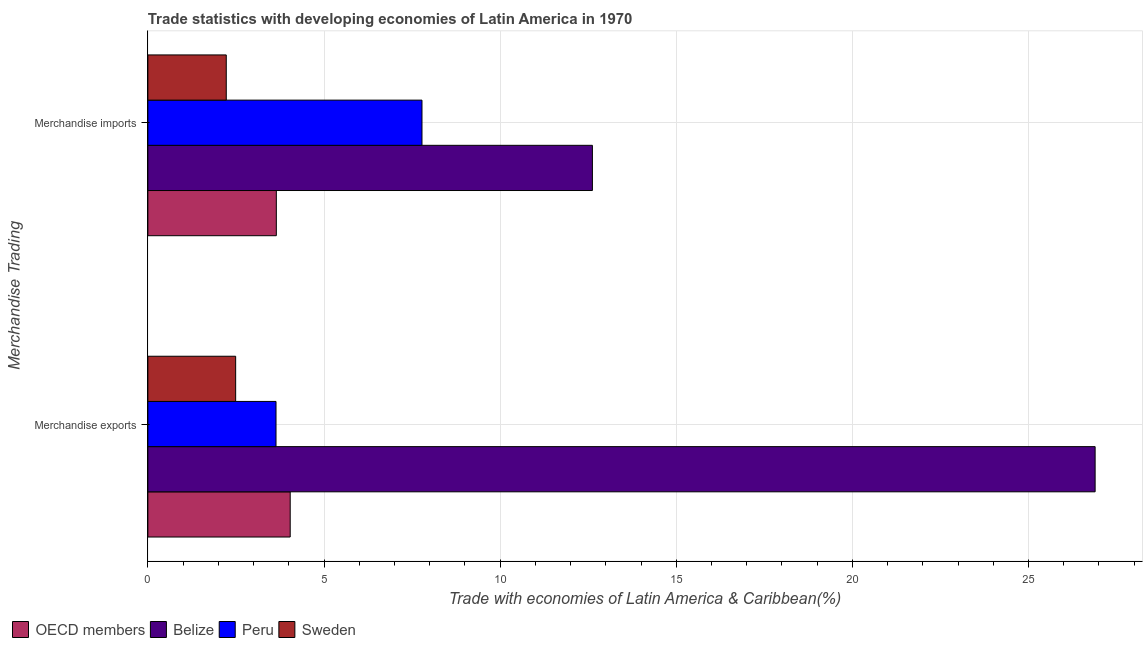Are the number of bars per tick equal to the number of legend labels?
Your response must be concise. Yes. Are the number of bars on each tick of the Y-axis equal?
Provide a succinct answer. Yes. How many bars are there on the 2nd tick from the bottom?
Make the answer very short. 4. What is the label of the 2nd group of bars from the top?
Make the answer very short. Merchandise exports. What is the merchandise exports in OECD members?
Offer a very short reply. 4.04. Across all countries, what is the maximum merchandise imports?
Your response must be concise. 12.62. Across all countries, what is the minimum merchandise imports?
Ensure brevity in your answer.  2.23. In which country was the merchandise imports maximum?
Offer a terse response. Belize. What is the total merchandise imports in the graph?
Ensure brevity in your answer.  26.27. What is the difference between the merchandise imports in Sweden and that in Peru?
Offer a terse response. -5.56. What is the difference between the merchandise imports in OECD members and the merchandise exports in Sweden?
Your answer should be compact. 1.15. What is the average merchandise exports per country?
Your answer should be very brief. 9.27. What is the difference between the merchandise imports and merchandise exports in Belize?
Offer a terse response. -14.27. What is the ratio of the merchandise imports in Peru to that in OECD members?
Provide a short and direct response. 2.13. Is the merchandise exports in Sweden less than that in Belize?
Give a very brief answer. Yes. In how many countries, is the merchandise exports greater than the average merchandise exports taken over all countries?
Make the answer very short. 1. What does the 2nd bar from the top in Merchandise imports represents?
Your response must be concise. Peru. How many bars are there?
Provide a short and direct response. 8. Are all the bars in the graph horizontal?
Ensure brevity in your answer.  Yes. How many countries are there in the graph?
Provide a succinct answer. 4. Does the graph contain any zero values?
Ensure brevity in your answer.  No. Does the graph contain grids?
Offer a terse response. Yes. Where does the legend appear in the graph?
Your answer should be compact. Bottom left. How many legend labels are there?
Your response must be concise. 4. How are the legend labels stacked?
Provide a short and direct response. Horizontal. What is the title of the graph?
Your response must be concise. Trade statistics with developing economies of Latin America in 1970. Does "Heavily indebted poor countries" appear as one of the legend labels in the graph?
Give a very brief answer. No. What is the label or title of the X-axis?
Ensure brevity in your answer.  Trade with economies of Latin America & Caribbean(%). What is the label or title of the Y-axis?
Your answer should be compact. Merchandise Trading. What is the Trade with economies of Latin America & Caribbean(%) in OECD members in Merchandise exports?
Your answer should be very brief. 4.04. What is the Trade with economies of Latin America & Caribbean(%) of Belize in Merchandise exports?
Provide a succinct answer. 26.89. What is the Trade with economies of Latin America & Caribbean(%) in Peru in Merchandise exports?
Offer a terse response. 3.64. What is the Trade with economies of Latin America & Caribbean(%) of Sweden in Merchandise exports?
Provide a succinct answer. 2.49. What is the Trade with economies of Latin America & Caribbean(%) in OECD members in Merchandise imports?
Your response must be concise. 3.65. What is the Trade with economies of Latin America & Caribbean(%) in Belize in Merchandise imports?
Give a very brief answer. 12.62. What is the Trade with economies of Latin America & Caribbean(%) of Peru in Merchandise imports?
Your response must be concise. 7.78. What is the Trade with economies of Latin America & Caribbean(%) in Sweden in Merchandise imports?
Make the answer very short. 2.23. Across all Merchandise Trading, what is the maximum Trade with economies of Latin America & Caribbean(%) of OECD members?
Give a very brief answer. 4.04. Across all Merchandise Trading, what is the maximum Trade with economies of Latin America & Caribbean(%) of Belize?
Ensure brevity in your answer.  26.89. Across all Merchandise Trading, what is the maximum Trade with economies of Latin America & Caribbean(%) of Peru?
Provide a short and direct response. 7.78. Across all Merchandise Trading, what is the maximum Trade with economies of Latin America & Caribbean(%) in Sweden?
Ensure brevity in your answer.  2.49. Across all Merchandise Trading, what is the minimum Trade with economies of Latin America & Caribbean(%) of OECD members?
Offer a very short reply. 3.65. Across all Merchandise Trading, what is the minimum Trade with economies of Latin America & Caribbean(%) in Belize?
Make the answer very short. 12.62. Across all Merchandise Trading, what is the minimum Trade with economies of Latin America & Caribbean(%) of Peru?
Make the answer very short. 3.64. Across all Merchandise Trading, what is the minimum Trade with economies of Latin America & Caribbean(%) in Sweden?
Give a very brief answer. 2.23. What is the total Trade with economies of Latin America & Caribbean(%) of OECD members in the graph?
Make the answer very short. 7.69. What is the total Trade with economies of Latin America & Caribbean(%) of Belize in the graph?
Provide a succinct answer. 39.51. What is the total Trade with economies of Latin America & Caribbean(%) in Peru in the graph?
Make the answer very short. 11.42. What is the total Trade with economies of Latin America & Caribbean(%) of Sweden in the graph?
Offer a terse response. 4.72. What is the difference between the Trade with economies of Latin America & Caribbean(%) in OECD members in Merchandise exports and that in Merchandise imports?
Ensure brevity in your answer.  0.39. What is the difference between the Trade with economies of Latin America & Caribbean(%) of Belize in Merchandise exports and that in Merchandise imports?
Offer a very short reply. 14.27. What is the difference between the Trade with economies of Latin America & Caribbean(%) of Peru in Merchandise exports and that in Merchandise imports?
Ensure brevity in your answer.  -4.14. What is the difference between the Trade with economies of Latin America & Caribbean(%) in Sweden in Merchandise exports and that in Merchandise imports?
Offer a very short reply. 0.27. What is the difference between the Trade with economies of Latin America & Caribbean(%) of OECD members in Merchandise exports and the Trade with economies of Latin America & Caribbean(%) of Belize in Merchandise imports?
Provide a succinct answer. -8.58. What is the difference between the Trade with economies of Latin America & Caribbean(%) of OECD members in Merchandise exports and the Trade with economies of Latin America & Caribbean(%) of Peru in Merchandise imports?
Your answer should be very brief. -3.74. What is the difference between the Trade with economies of Latin America & Caribbean(%) of OECD members in Merchandise exports and the Trade with economies of Latin America & Caribbean(%) of Sweden in Merchandise imports?
Provide a short and direct response. 1.82. What is the difference between the Trade with economies of Latin America & Caribbean(%) in Belize in Merchandise exports and the Trade with economies of Latin America & Caribbean(%) in Peru in Merchandise imports?
Give a very brief answer. 19.11. What is the difference between the Trade with economies of Latin America & Caribbean(%) in Belize in Merchandise exports and the Trade with economies of Latin America & Caribbean(%) in Sweden in Merchandise imports?
Keep it short and to the point. 24.67. What is the difference between the Trade with economies of Latin America & Caribbean(%) in Peru in Merchandise exports and the Trade with economies of Latin America & Caribbean(%) in Sweden in Merchandise imports?
Offer a terse response. 1.41. What is the average Trade with economies of Latin America & Caribbean(%) of OECD members per Merchandise Trading?
Offer a terse response. 3.84. What is the average Trade with economies of Latin America & Caribbean(%) of Belize per Merchandise Trading?
Offer a terse response. 19.76. What is the average Trade with economies of Latin America & Caribbean(%) of Peru per Merchandise Trading?
Your answer should be compact. 5.71. What is the average Trade with economies of Latin America & Caribbean(%) of Sweden per Merchandise Trading?
Provide a succinct answer. 2.36. What is the difference between the Trade with economies of Latin America & Caribbean(%) of OECD members and Trade with economies of Latin America & Caribbean(%) of Belize in Merchandise exports?
Provide a short and direct response. -22.85. What is the difference between the Trade with economies of Latin America & Caribbean(%) in OECD members and Trade with economies of Latin America & Caribbean(%) in Peru in Merchandise exports?
Your answer should be very brief. 0.4. What is the difference between the Trade with economies of Latin America & Caribbean(%) in OECD members and Trade with economies of Latin America & Caribbean(%) in Sweden in Merchandise exports?
Ensure brevity in your answer.  1.55. What is the difference between the Trade with economies of Latin America & Caribbean(%) in Belize and Trade with economies of Latin America & Caribbean(%) in Peru in Merchandise exports?
Provide a succinct answer. 23.25. What is the difference between the Trade with economies of Latin America & Caribbean(%) in Belize and Trade with economies of Latin America & Caribbean(%) in Sweden in Merchandise exports?
Provide a short and direct response. 24.4. What is the difference between the Trade with economies of Latin America & Caribbean(%) of Peru and Trade with economies of Latin America & Caribbean(%) of Sweden in Merchandise exports?
Ensure brevity in your answer.  1.15. What is the difference between the Trade with economies of Latin America & Caribbean(%) in OECD members and Trade with economies of Latin America & Caribbean(%) in Belize in Merchandise imports?
Offer a terse response. -8.97. What is the difference between the Trade with economies of Latin America & Caribbean(%) of OECD members and Trade with economies of Latin America & Caribbean(%) of Peru in Merchandise imports?
Make the answer very short. -4.13. What is the difference between the Trade with economies of Latin America & Caribbean(%) of OECD members and Trade with economies of Latin America & Caribbean(%) of Sweden in Merchandise imports?
Give a very brief answer. 1.42. What is the difference between the Trade with economies of Latin America & Caribbean(%) of Belize and Trade with economies of Latin America & Caribbean(%) of Peru in Merchandise imports?
Offer a terse response. 4.84. What is the difference between the Trade with economies of Latin America & Caribbean(%) of Belize and Trade with economies of Latin America & Caribbean(%) of Sweden in Merchandise imports?
Offer a terse response. 10.39. What is the difference between the Trade with economies of Latin America & Caribbean(%) of Peru and Trade with economies of Latin America & Caribbean(%) of Sweden in Merchandise imports?
Your answer should be very brief. 5.56. What is the ratio of the Trade with economies of Latin America & Caribbean(%) in OECD members in Merchandise exports to that in Merchandise imports?
Your answer should be very brief. 1.11. What is the ratio of the Trade with economies of Latin America & Caribbean(%) in Belize in Merchandise exports to that in Merchandise imports?
Ensure brevity in your answer.  2.13. What is the ratio of the Trade with economies of Latin America & Caribbean(%) of Peru in Merchandise exports to that in Merchandise imports?
Offer a terse response. 0.47. What is the ratio of the Trade with economies of Latin America & Caribbean(%) of Sweden in Merchandise exports to that in Merchandise imports?
Ensure brevity in your answer.  1.12. What is the difference between the highest and the second highest Trade with economies of Latin America & Caribbean(%) in OECD members?
Your answer should be very brief. 0.39. What is the difference between the highest and the second highest Trade with economies of Latin America & Caribbean(%) of Belize?
Provide a short and direct response. 14.27. What is the difference between the highest and the second highest Trade with economies of Latin America & Caribbean(%) in Peru?
Your response must be concise. 4.14. What is the difference between the highest and the second highest Trade with economies of Latin America & Caribbean(%) in Sweden?
Ensure brevity in your answer.  0.27. What is the difference between the highest and the lowest Trade with economies of Latin America & Caribbean(%) of OECD members?
Your answer should be very brief. 0.39. What is the difference between the highest and the lowest Trade with economies of Latin America & Caribbean(%) in Belize?
Provide a short and direct response. 14.27. What is the difference between the highest and the lowest Trade with economies of Latin America & Caribbean(%) in Peru?
Keep it short and to the point. 4.14. What is the difference between the highest and the lowest Trade with economies of Latin America & Caribbean(%) of Sweden?
Your response must be concise. 0.27. 